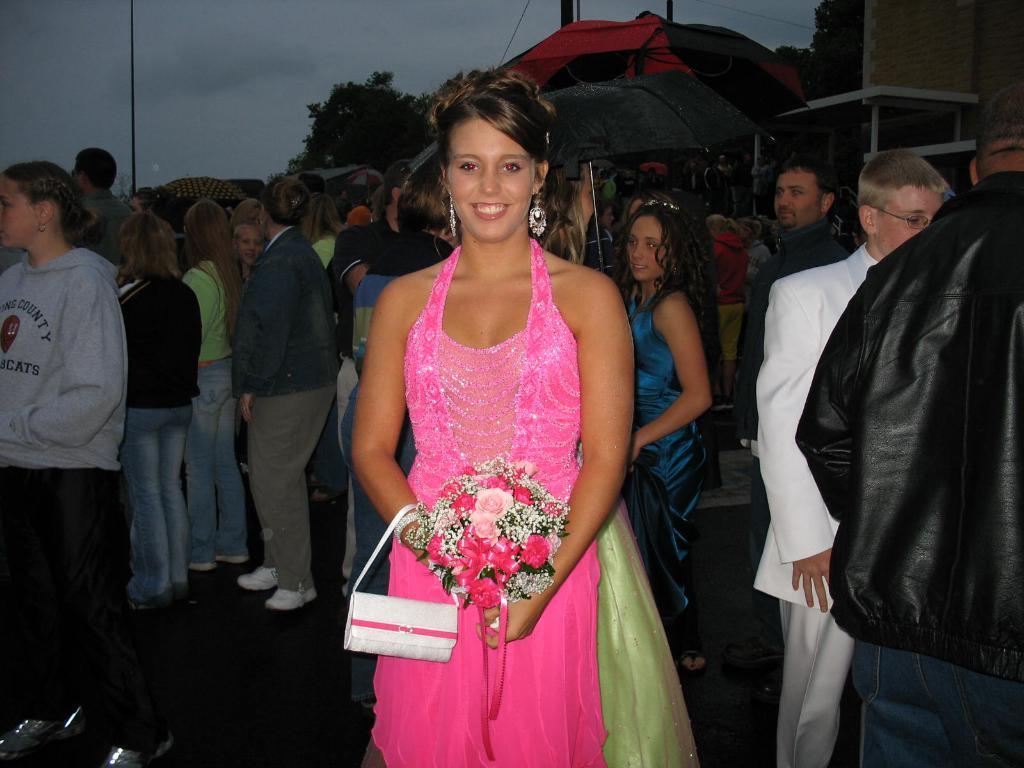In one or two sentences, can you explain what this image depicts? In the center of the image we can see a lady standing and holding a flower bouquet. In the background there are people and we can see buildings. There are trees. At the top there is sky and we can see poles. 